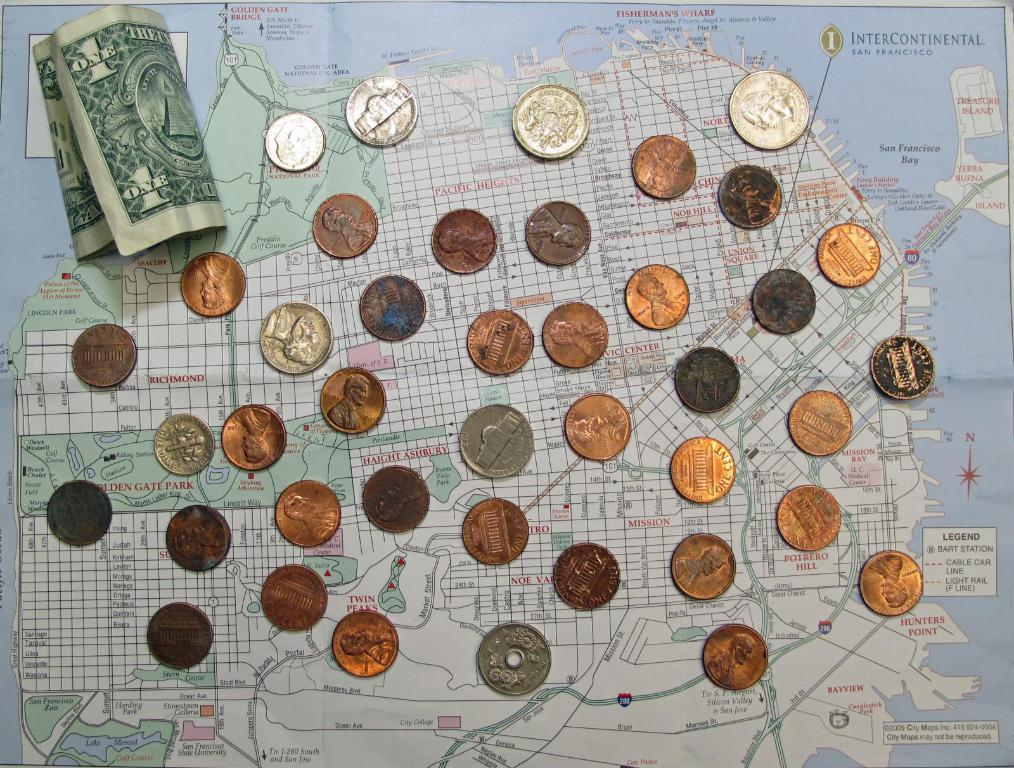<image>
Relay a brief, clear account of the picture shown. Assorted coins and a one dollar bill are laid out on a San Francisco map. 